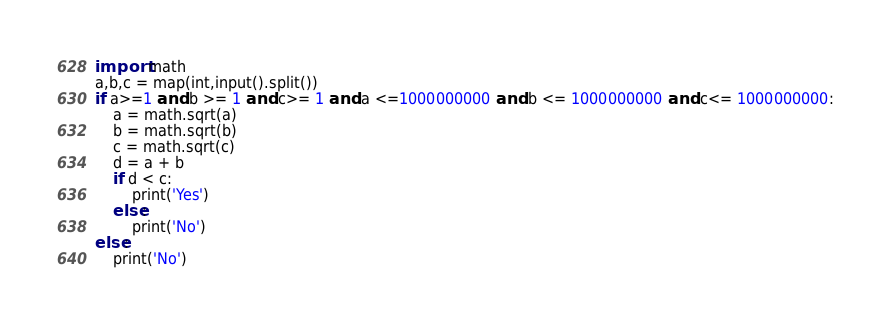Convert code to text. <code><loc_0><loc_0><loc_500><loc_500><_Python_>import math
a,b,c = map(int,input().split())
if a>=1 and b >= 1 and c>= 1 and a <=1000000000 and b <= 1000000000 and c<= 1000000000:
    a = math.sqrt(a)
    b = math.sqrt(b)
    c = math.sqrt(c)
    d = a + b
    if d < c:
        print('Yes')
    else:
        print('No')
else:
    print('No')</code> 